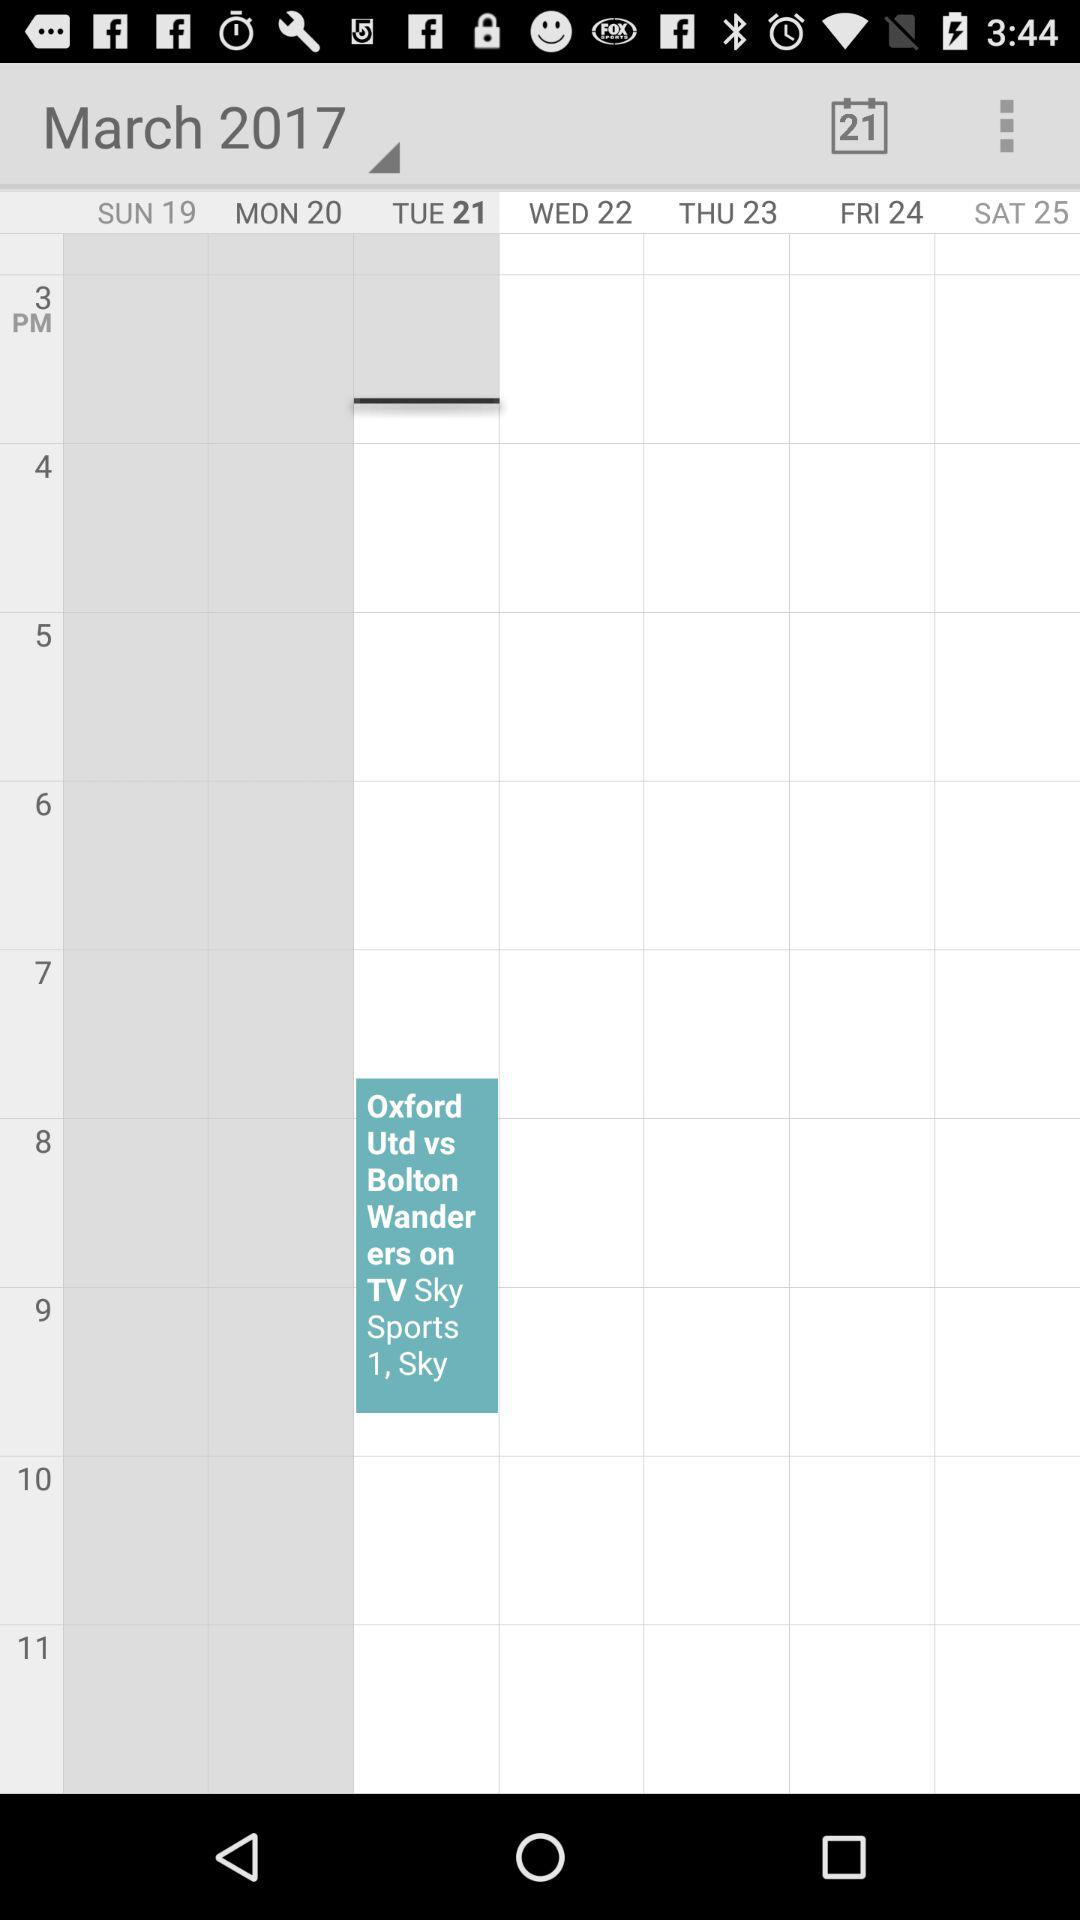What is the selected date? The selected date is Tuesday, March 21, 2017. 